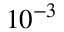Convert formula to latex. <formula><loc_0><loc_0><loc_500><loc_500>1 0 ^ { - 3 }</formula> 